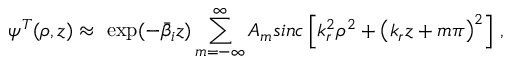<formula> <loc_0><loc_0><loc_500><loc_500>\psi ^ { T } ( \rho , z ) \approx \ \exp ( - \bar { \beta } _ { i } z ) \sum _ { m = - \infty } ^ { \infty } A _ { m } \sin c \left [ k _ { r } ^ { 2 } \rho ^ { 2 } + \left ( k _ { r } z + m \pi \right ) ^ { 2 } \right ] \, ,</formula> 